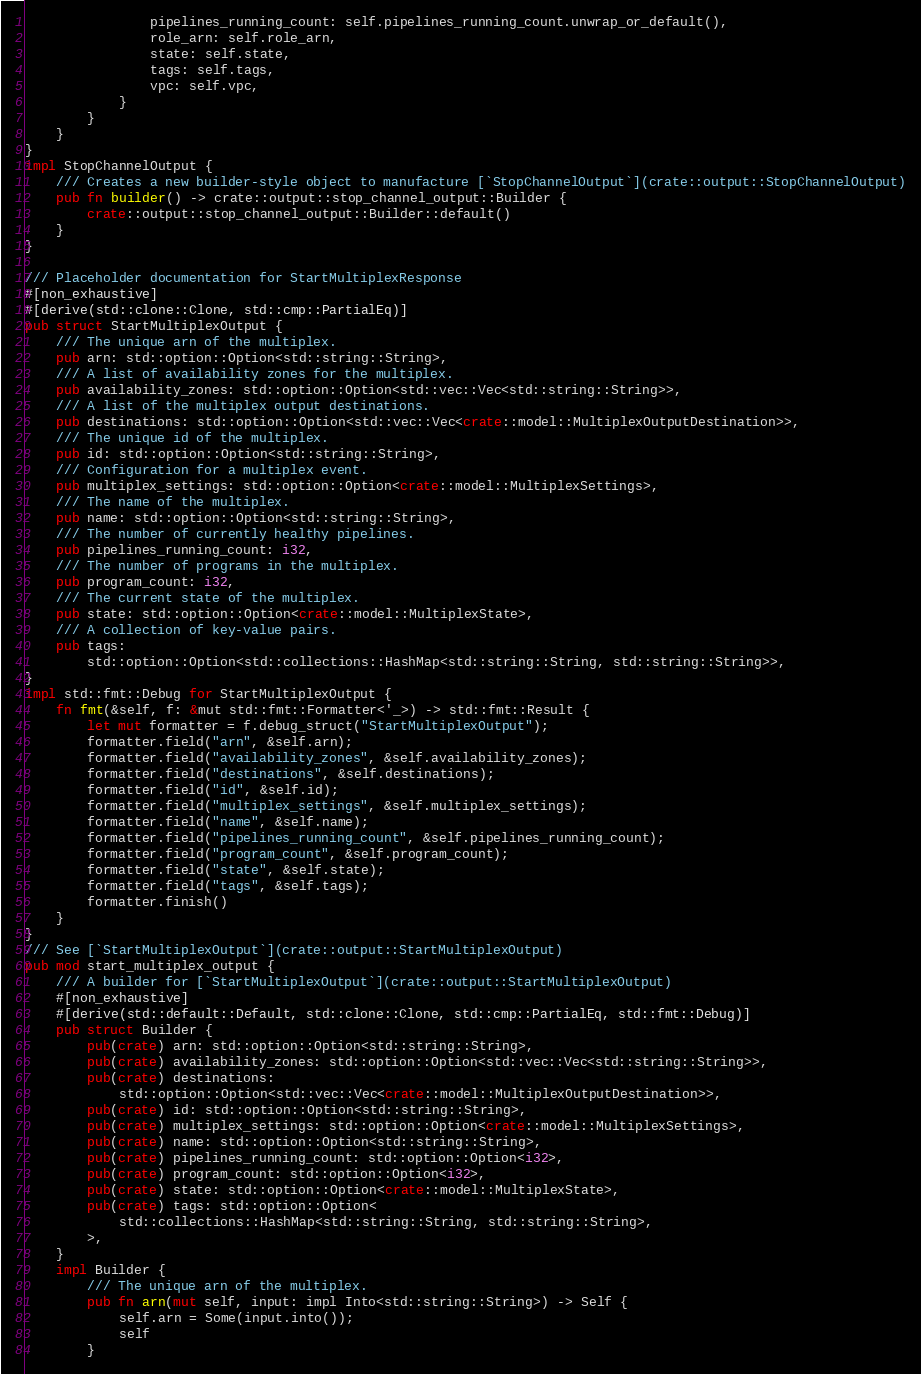Convert code to text. <code><loc_0><loc_0><loc_500><loc_500><_Rust_>                pipelines_running_count: self.pipelines_running_count.unwrap_or_default(),
                role_arn: self.role_arn,
                state: self.state,
                tags: self.tags,
                vpc: self.vpc,
            }
        }
    }
}
impl StopChannelOutput {
    /// Creates a new builder-style object to manufacture [`StopChannelOutput`](crate::output::StopChannelOutput)
    pub fn builder() -> crate::output::stop_channel_output::Builder {
        crate::output::stop_channel_output::Builder::default()
    }
}

/// Placeholder documentation for StartMultiplexResponse
#[non_exhaustive]
#[derive(std::clone::Clone, std::cmp::PartialEq)]
pub struct StartMultiplexOutput {
    /// The unique arn of the multiplex.
    pub arn: std::option::Option<std::string::String>,
    /// A list of availability zones for the multiplex.
    pub availability_zones: std::option::Option<std::vec::Vec<std::string::String>>,
    /// A list of the multiplex output destinations.
    pub destinations: std::option::Option<std::vec::Vec<crate::model::MultiplexOutputDestination>>,
    /// The unique id of the multiplex.
    pub id: std::option::Option<std::string::String>,
    /// Configuration for a multiplex event.
    pub multiplex_settings: std::option::Option<crate::model::MultiplexSettings>,
    /// The name of the multiplex.
    pub name: std::option::Option<std::string::String>,
    /// The number of currently healthy pipelines.
    pub pipelines_running_count: i32,
    /// The number of programs in the multiplex.
    pub program_count: i32,
    /// The current state of the multiplex.
    pub state: std::option::Option<crate::model::MultiplexState>,
    /// A collection of key-value pairs.
    pub tags:
        std::option::Option<std::collections::HashMap<std::string::String, std::string::String>>,
}
impl std::fmt::Debug for StartMultiplexOutput {
    fn fmt(&self, f: &mut std::fmt::Formatter<'_>) -> std::fmt::Result {
        let mut formatter = f.debug_struct("StartMultiplexOutput");
        formatter.field("arn", &self.arn);
        formatter.field("availability_zones", &self.availability_zones);
        formatter.field("destinations", &self.destinations);
        formatter.field("id", &self.id);
        formatter.field("multiplex_settings", &self.multiplex_settings);
        formatter.field("name", &self.name);
        formatter.field("pipelines_running_count", &self.pipelines_running_count);
        formatter.field("program_count", &self.program_count);
        formatter.field("state", &self.state);
        formatter.field("tags", &self.tags);
        formatter.finish()
    }
}
/// See [`StartMultiplexOutput`](crate::output::StartMultiplexOutput)
pub mod start_multiplex_output {
    /// A builder for [`StartMultiplexOutput`](crate::output::StartMultiplexOutput)
    #[non_exhaustive]
    #[derive(std::default::Default, std::clone::Clone, std::cmp::PartialEq, std::fmt::Debug)]
    pub struct Builder {
        pub(crate) arn: std::option::Option<std::string::String>,
        pub(crate) availability_zones: std::option::Option<std::vec::Vec<std::string::String>>,
        pub(crate) destinations:
            std::option::Option<std::vec::Vec<crate::model::MultiplexOutputDestination>>,
        pub(crate) id: std::option::Option<std::string::String>,
        pub(crate) multiplex_settings: std::option::Option<crate::model::MultiplexSettings>,
        pub(crate) name: std::option::Option<std::string::String>,
        pub(crate) pipelines_running_count: std::option::Option<i32>,
        pub(crate) program_count: std::option::Option<i32>,
        pub(crate) state: std::option::Option<crate::model::MultiplexState>,
        pub(crate) tags: std::option::Option<
            std::collections::HashMap<std::string::String, std::string::String>,
        >,
    }
    impl Builder {
        /// The unique arn of the multiplex.
        pub fn arn(mut self, input: impl Into<std::string::String>) -> Self {
            self.arn = Some(input.into());
            self
        }</code> 